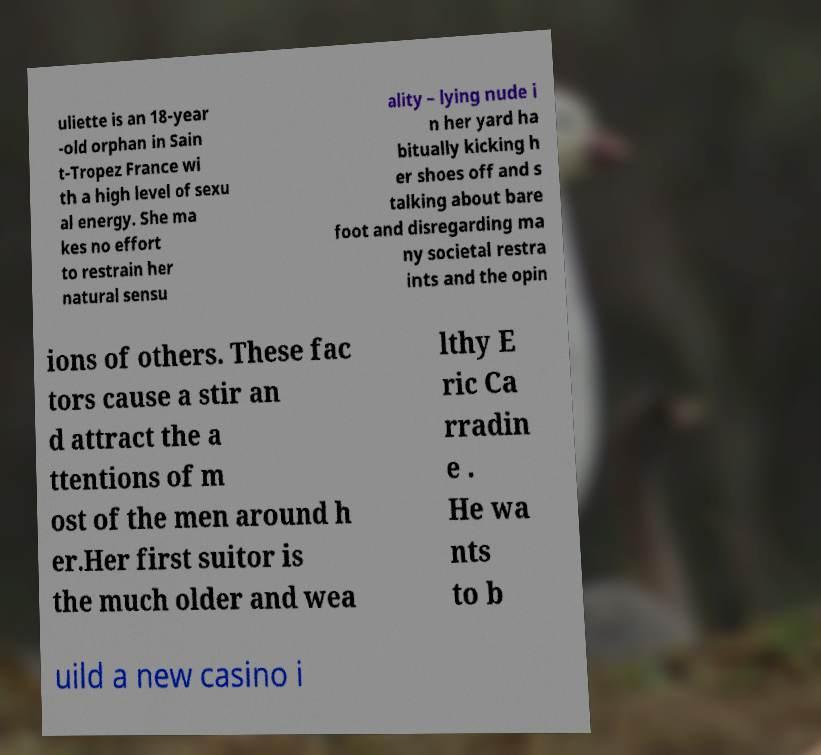Please read and relay the text visible in this image. What does it say? uliette is an 18-year -old orphan in Sain t-Tropez France wi th a high level of sexu al energy. She ma kes no effort to restrain her natural sensu ality – lying nude i n her yard ha bitually kicking h er shoes off and s talking about bare foot and disregarding ma ny societal restra ints and the opin ions of others. These fac tors cause a stir an d attract the a ttentions of m ost of the men around h er.Her first suitor is the much older and wea lthy E ric Ca rradin e . He wa nts to b uild a new casino i 